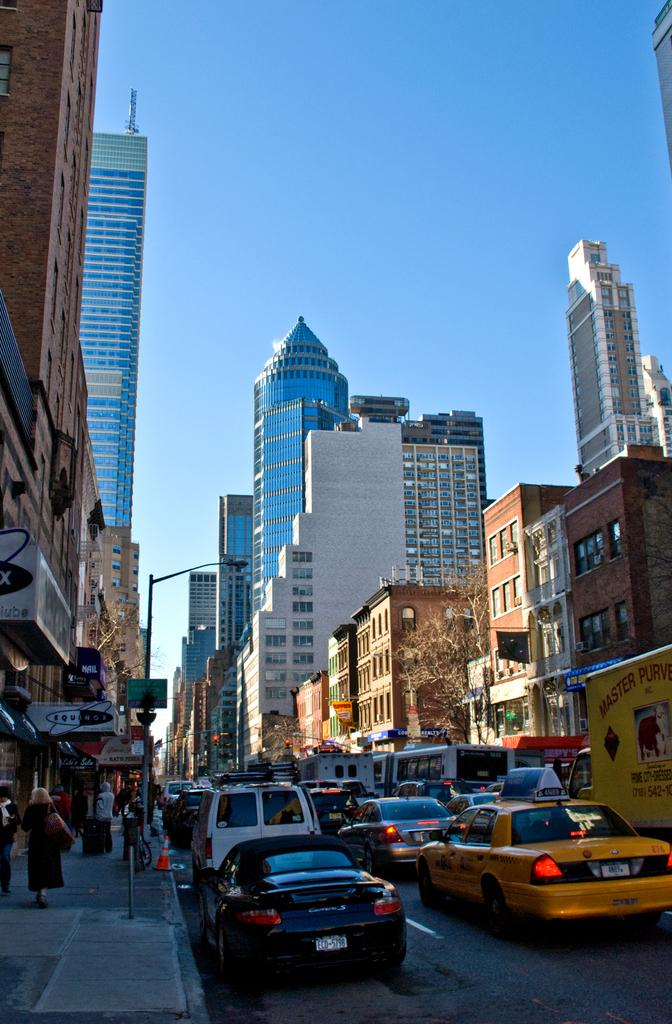<image>
Render a clear and concise summary of the photo. A street scene with a car with ECD on it. 